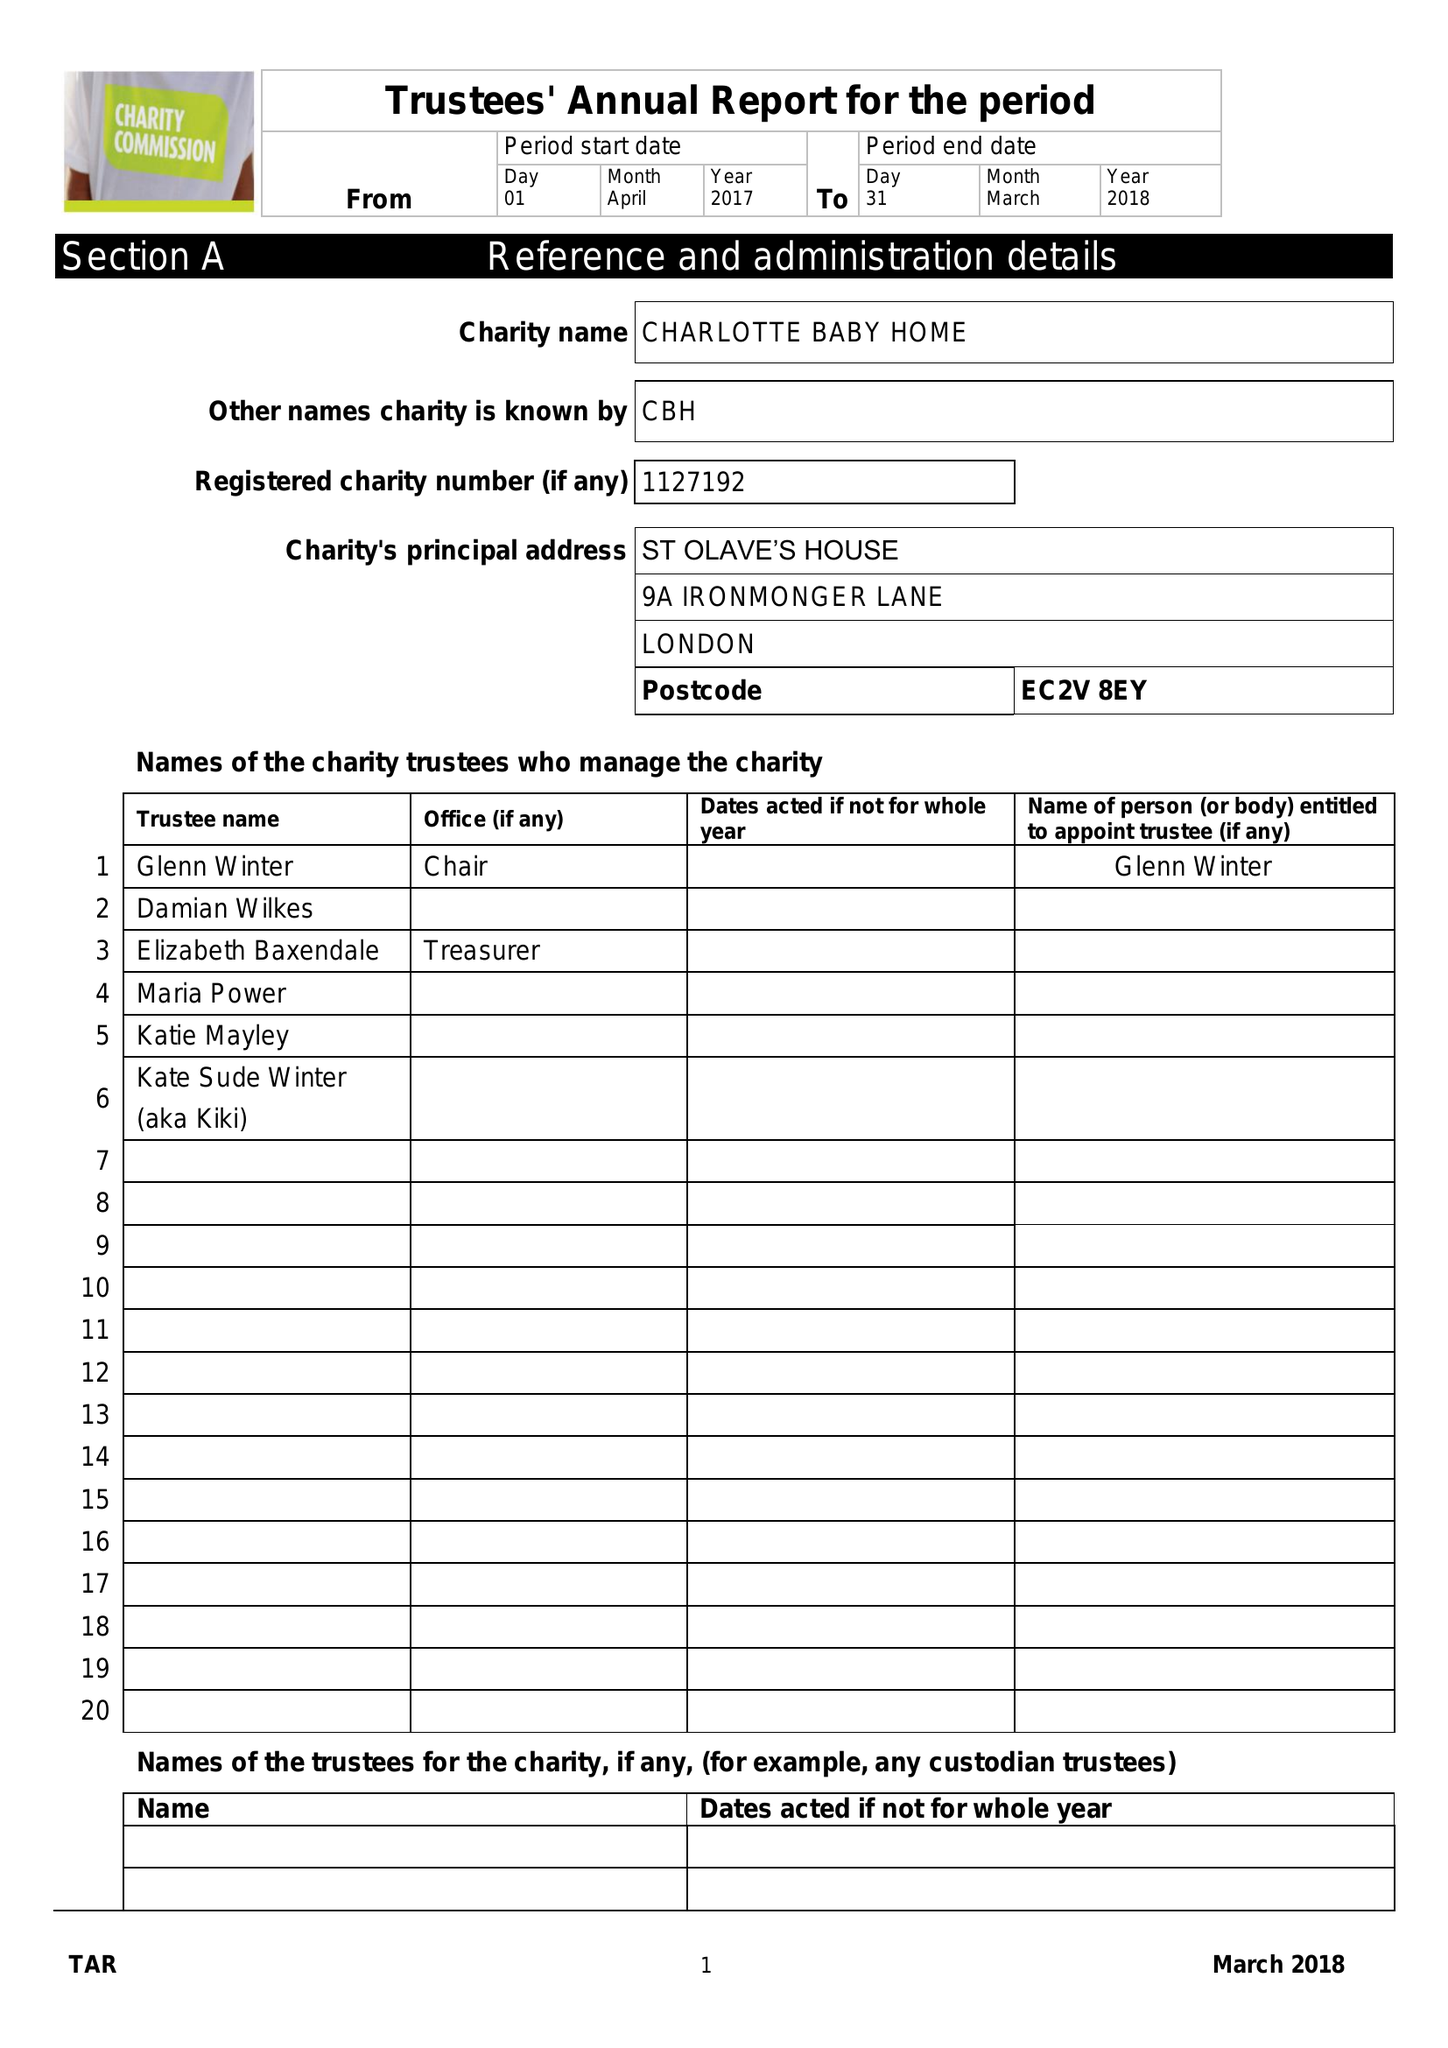What is the value for the spending_annually_in_british_pounds?
Answer the question using a single word or phrase. 52250.00 